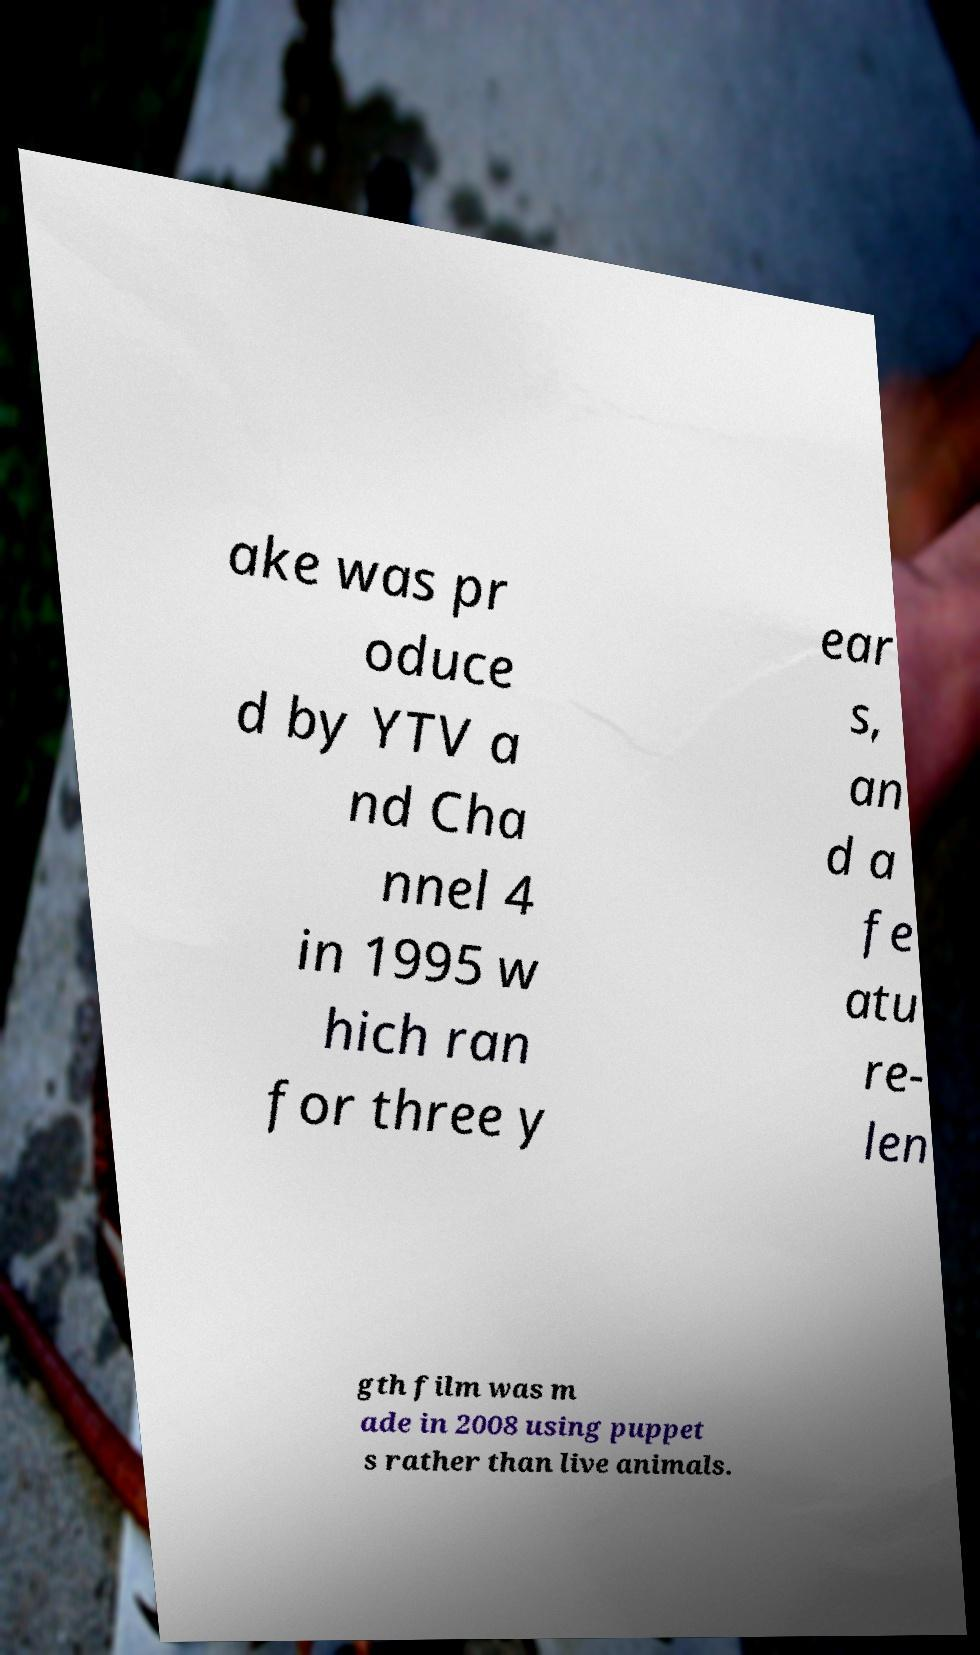Could you extract and type out the text from this image? ake was pr oduce d by YTV a nd Cha nnel 4 in 1995 w hich ran for three y ear s, an d a fe atu re- len gth film was m ade in 2008 using puppet s rather than live animals. 